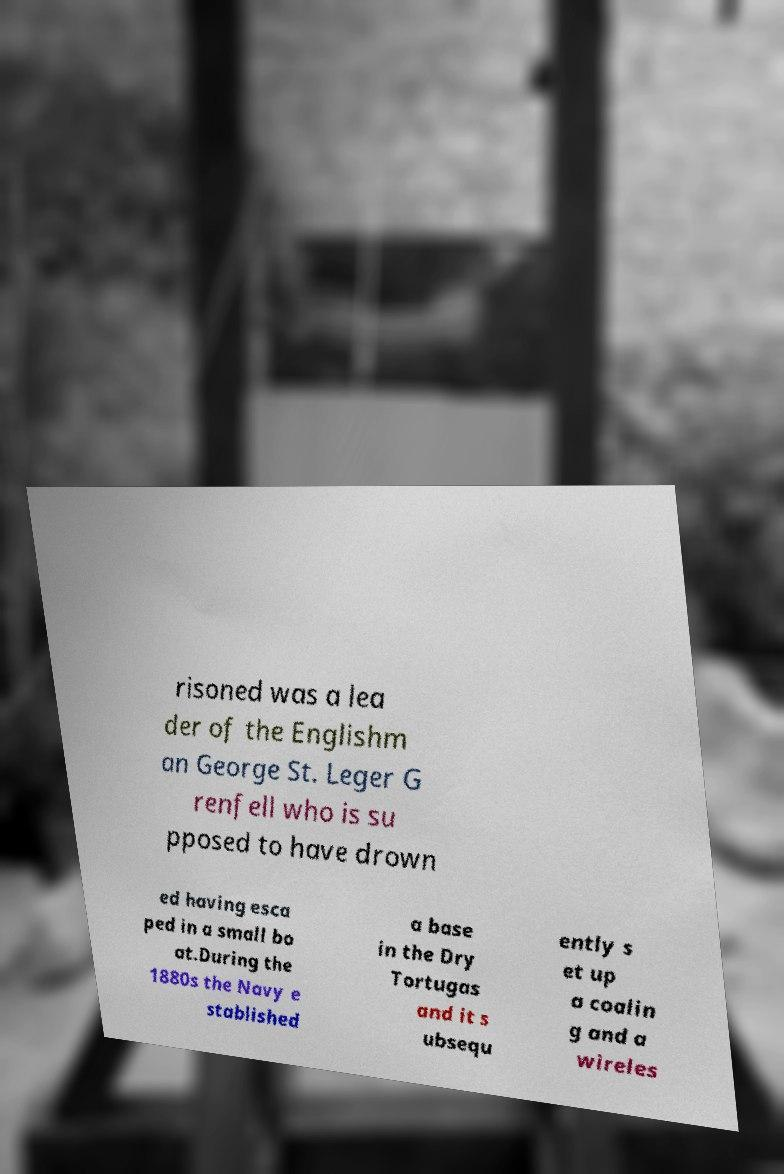Please read and relay the text visible in this image. What does it say? risoned was a lea der of the Englishm an George St. Leger G renfell who is su pposed to have drown ed having esca ped in a small bo at.During the 1880s the Navy e stablished a base in the Dry Tortugas and it s ubsequ ently s et up a coalin g and a wireles 